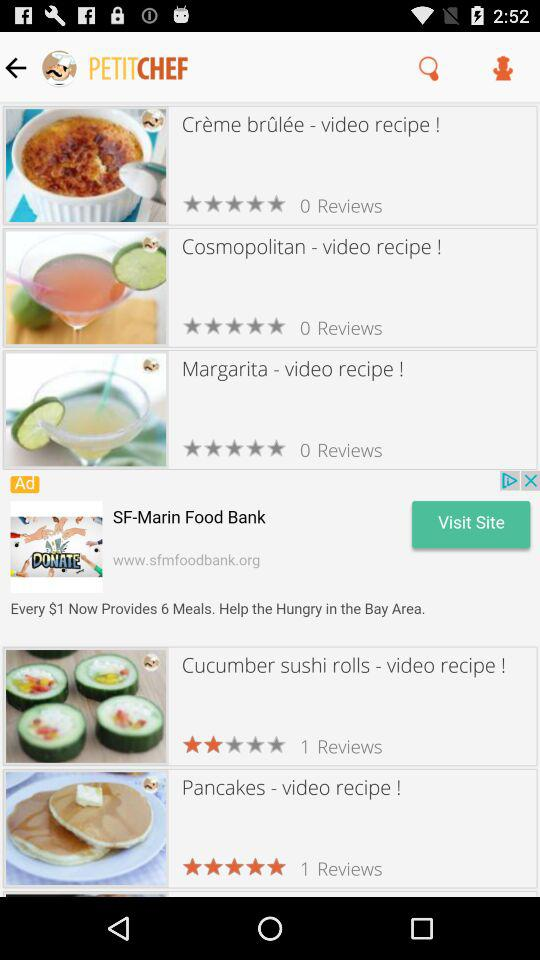How many reviews are there for "Margarita"? There are 0 reviews for "Margarita". 